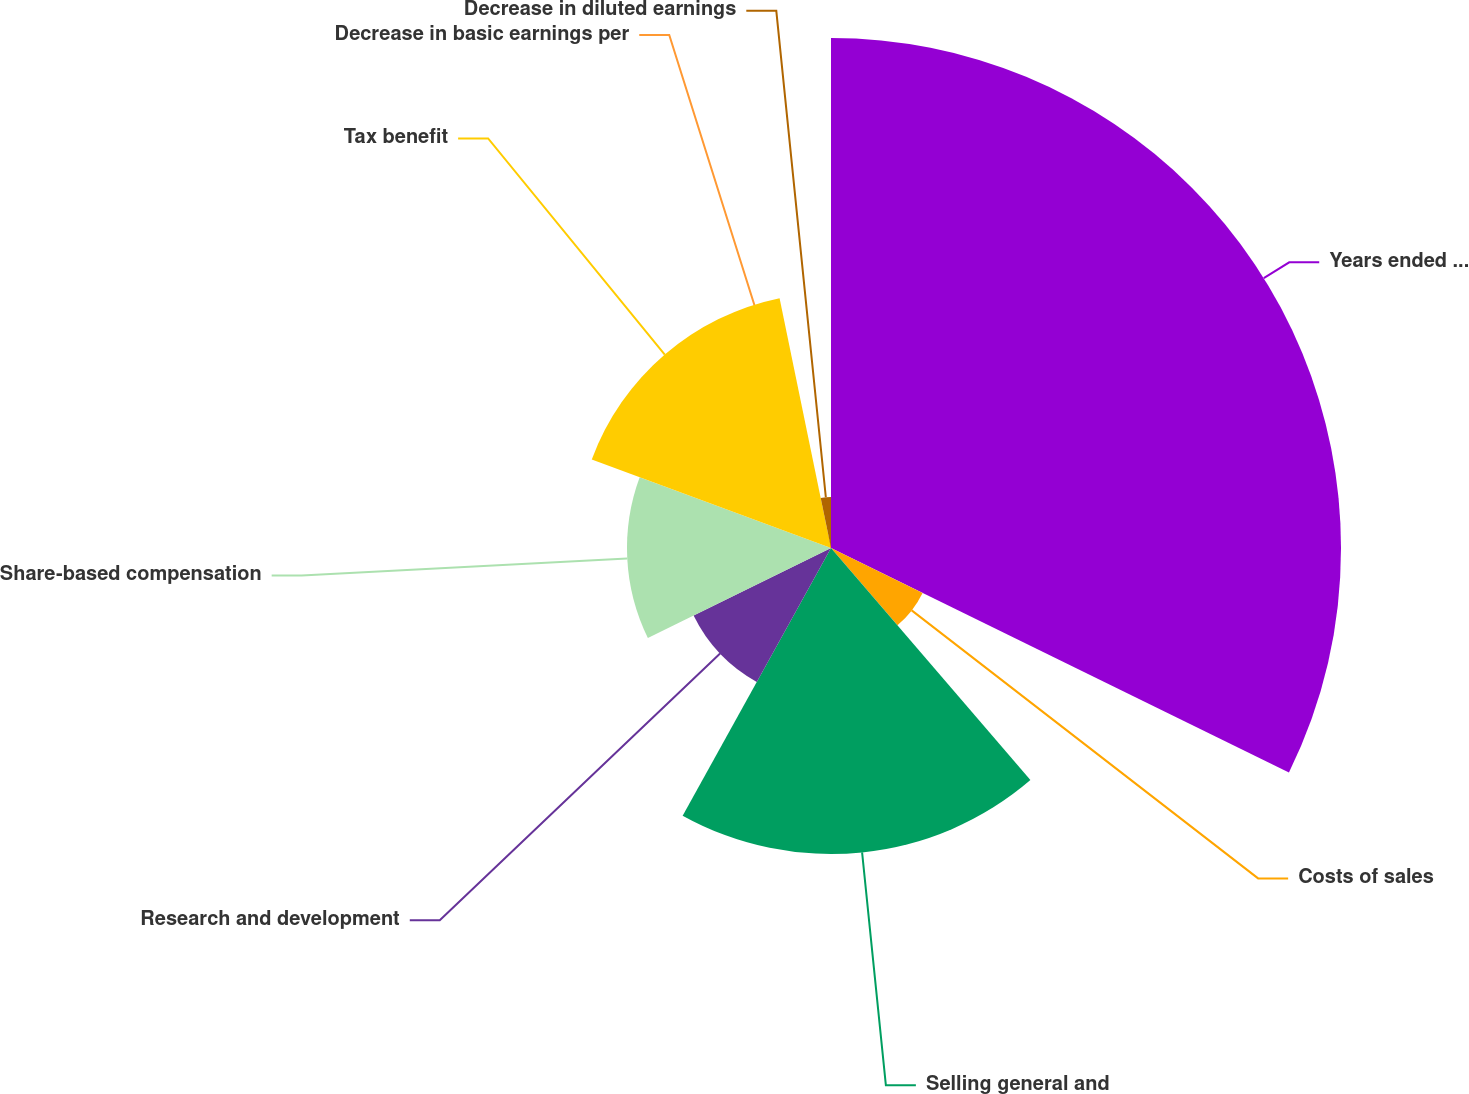Convert chart. <chart><loc_0><loc_0><loc_500><loc_500><pie_chart><fcel>Years ended December 31<fcel>Costs of sales<fcel>Selling general and<fcel>Research and development<fcel>Share-based compensation<fcel>Tax benefit<fcel>Decrease in basic earnings per<fcel>Decrease in diluted earnings<nl><fcel>32.25%<fcel>6.45%<fcel>19.35%<fcel>9.68%<fcel>12.9%<fcel>16.13%<fcel>0.0%<fcel>3.23%<nl></chart> 